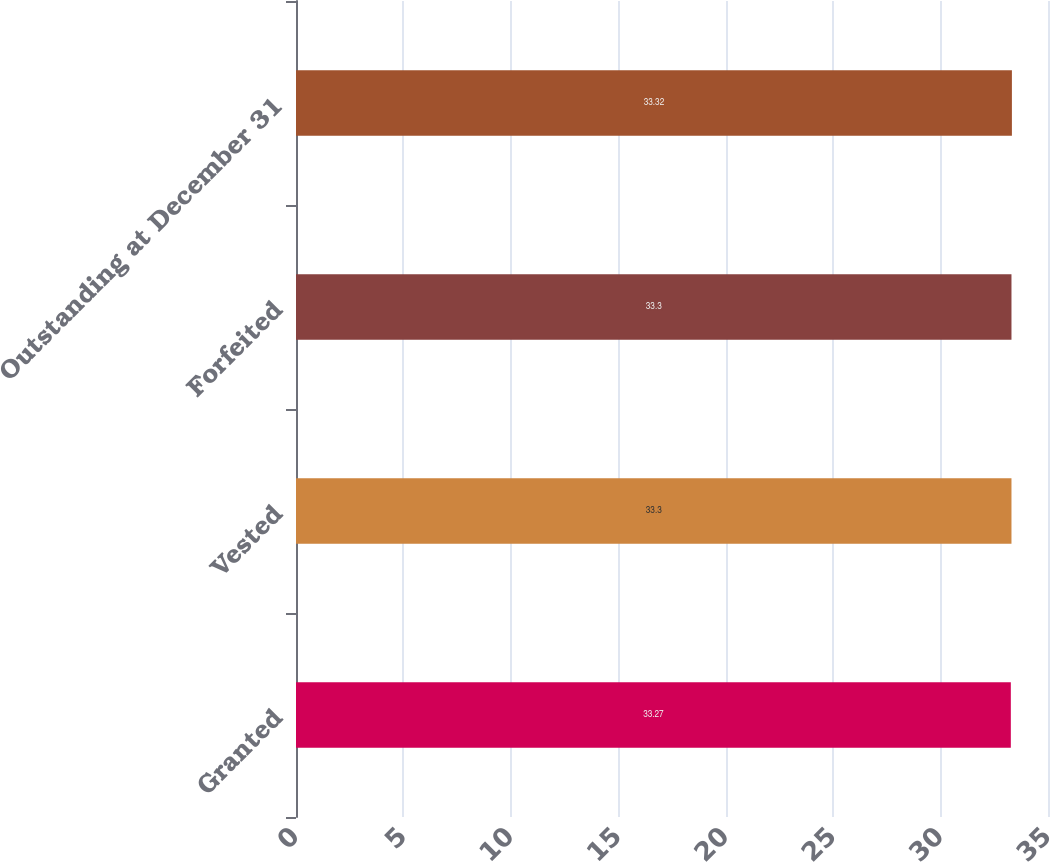Convert chart. <chart><loc_0><loc_0><loc_500><loc_500><bar_chart><fcel>Granted<fcel>Vested<fcel>Forfeited<fcel>Outstanding at December 31<nl><fcel>33.27<fcel>33.3<fcel>33.3<fcel>33.32<nl></chart> 